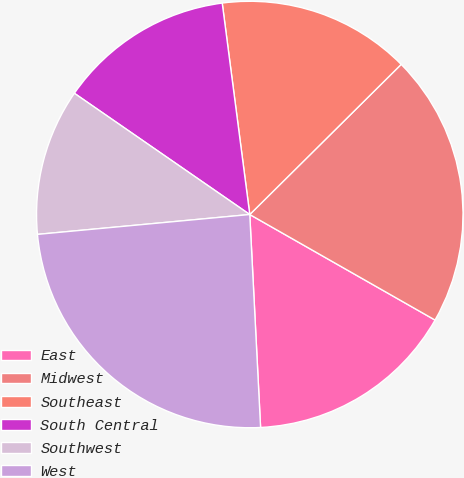<chart> <loc_0><loc_0><loc_500><loc_500><pie_chart><fcel>East<fcel>Midwest<fcel>Southeast<fcel>South Central<fcel>Southwest<fcel>West<nl><fcel>15.95%<fcel>20.67%<fcel>14.63%<fcel>13.31%<fcel>11.11%<fcel>24.32%<nl></chart> 